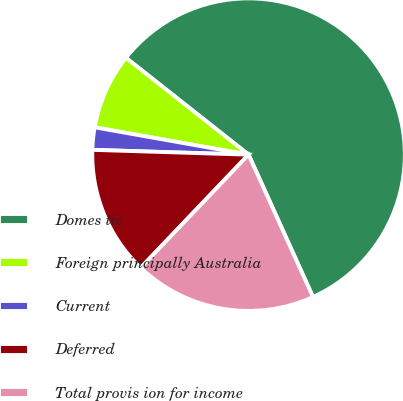Convert chart to OTSL. <chart><loc_0><loc_0><loc_500><loc_500><pie_chart><fcel>Domes tic<fcel>Foreign principally Australia<fcel>Current<fcel>Deferred<fcel>Total provis ion for income<nl><fcel>57.6%<fcel>7.84%<fcel>2.31%<fcel>13.37%<fcel>18.89%<nl></chart> 